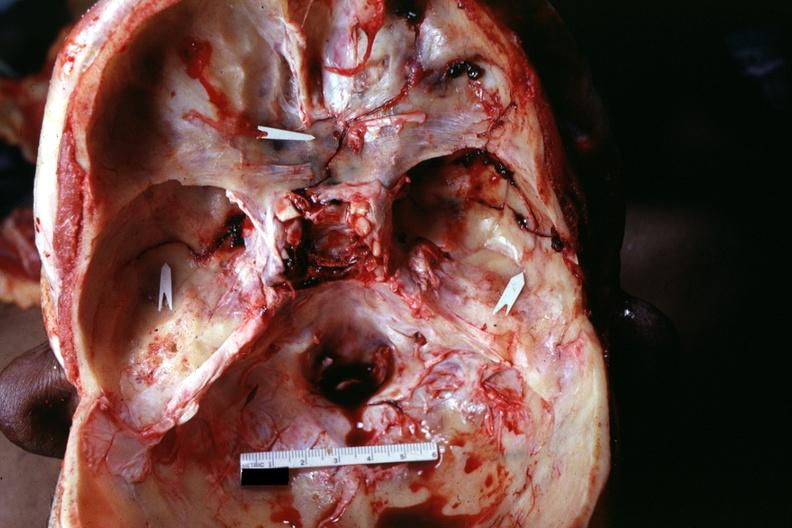does this image show multiple fractures very well?
Answer the question using a single word or phrase. Yes 